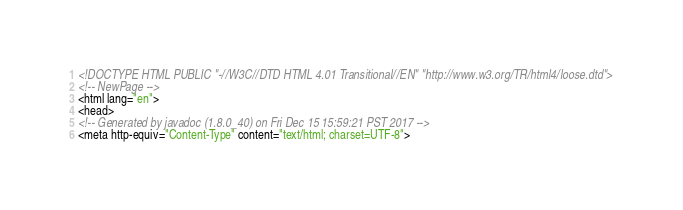<code> <loc_0><loc_0><loc_500><loc_500><_HTML_><!DOCTYPE HTML PUBLIC "-//W3C//DTD HTML 4.01 Transitional//EN" "http://www.w3.org/TR/html4/loose.dtd">
<!-- NewPage -->
<html lang="en">
<head>
<!-- Generated by javadoc (1.8.0_40) on Fri Dec 15 15:59:21 PST 2017 -->
<meta http-equiv="Content-Type" content="text/html; charset=UTF-8"></code> 